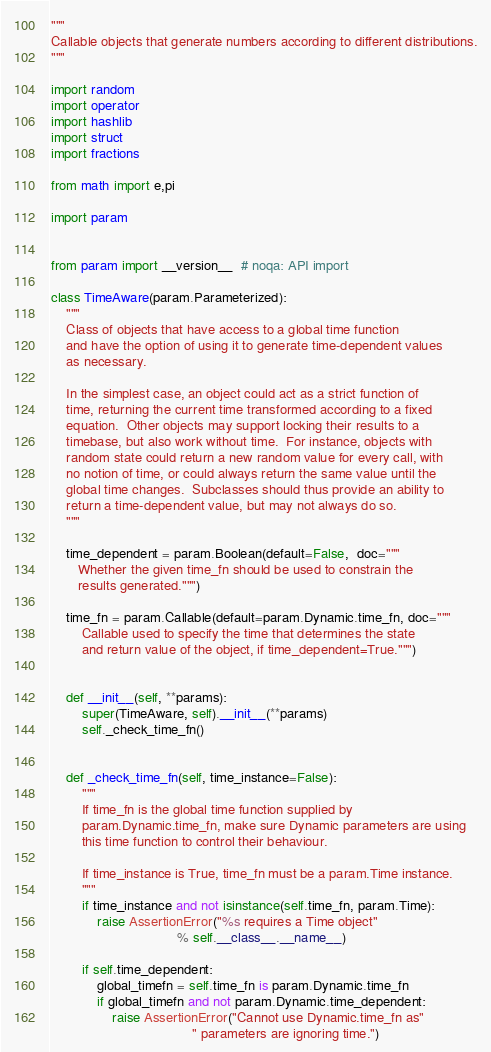Convert code to text. <code><loc_0><loc_0><loc_500><loc_500><_Python_>"""
Callable objects that generate numbers according to different distributions.
"""

import random
import operator
import hashlib
import struct
import fractions

from math import e,pi

import param


from param import __version__  # noqa: API import

class TimeAware(param.Parameterized):
    """
    Class of objects that have access to a global time function
    and have the option of using it to generate time-dependent values
    as necessary.

    In the simplest case, an object could act as a strict function of
    time, returning the current time transformed according to a fixed
    equation.  Other objects may support locking their results to a
    timebase, but also work without time.  For instance, objects with
    random state could return a new random value for every call, with
    no notion of time, or could always return the same value until the
    global time changes.  Subclasses should thus provide an ability to
    return a time-dependent value, but may not always do so.
    """

    time_dependent = param.Boolean(default=False,  doc="""
       Whether the given time_fn should be used to constrain the
       results generated.""")

    time_fn = param.Callable(default=param.Dynamic.time_fn, doc="""
        Callable used to specify the time that determines the state
        and return value of the object, if time_dependent=True.""")


    def __init__(self, **params):
        super(TimeAware, self).__init__(**params)
        self._check_time_fn()


    def _check_time_fn(self, time_instance=False):
        """
        If time_fn is the global time function supplied by
        param.Dynamic.time_fn, make sure Dynamic parameters are using
        this time function to control their behaviour.

        If time_instance is True, time_fn must be a param.Time instance.
        """
        if time_instance and not isinstance(self.time_fn, param.Time):
            raise AssertionError("%s requires a Time object"
                                 % self.__class__.__name__)

        if self.time_dependent:
            global_timefn = self.time_fn is param.Dynamic.time_fn
            if global_timefn and not param.Dynamic.time_dependent:
                raise AssertionError("Cannot use Dynamic.time_fn as"
                                     " parameters are ignoring time.")

</code> 